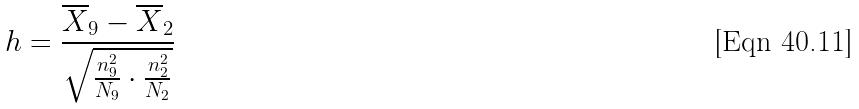<formula> <loc_0><loc_0><loc_500><loc_500>h = \frac { \overline { X } _ { 9 } - \overline { X } _ { 2 } } { \sqrt { \frac { n _ { 9 } ^ { 2 } } { N _ { 9 } } \cdot \frac { n _ { 2 } ^ { 2 } } { N _ { 2 } } } }</formula> 